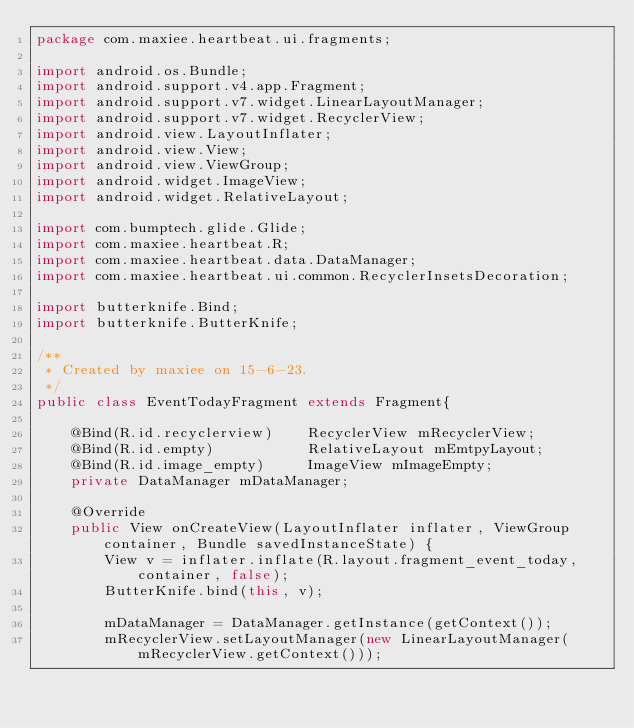<code> <loc_0><loc_0><loc_500><loc_500><_Java_>package com.maxiee.heartbeat.ui.fragments;

import android.os.Bundle;
import android.support.v4.app.Fragment;
import android.support.v7.widget.LinearLayoutManager;
import android.support.v7.widget.RecyclerView;
import android.view.LayoutInflater;
import android.view.View;
import android.view.ViewGroup;
import android.widget.ImageView;
import android.widget.RelativeLayout;

import com.bumptech.glide.Glide;
import com.maxiee.heartbeat.R;
import com.maxiee.heartbeat.data.DataManager;
import com.maxiee.heartbeat.ui.common.RecyclerInsetsDecoration;

import butterknife.Bind;
import butterknife.ButterKnife;

/**
 * Created by maxiee on 15-6-23.
 */
public class EventTodayFragment extends Fragment{

    @Bind(R.id.recyclerview)    RecyclerView mRecyclerView;
    @Bind(R.id.empty)           RelativeLayout mEmtpyLayout;
    @Bind(R.id.image_empty)     ImageView mImageEmpty;
    private DataManager mDataManager;

    @Override
    public View onCreateView(LayoutInflater inflater, ViewGroup container, Bundle savedInstanceState) {
        View v = inflater.inflate(R.layout.fragment_event_today, container, false);
        ButterKnife.bind(this, v);

        mDataManager = DataManager.getInstance(getContext());
        mRecyclerView.setLayoutManager(new LinearLayoutManager(mRecyclerView.getContext()));</code> 